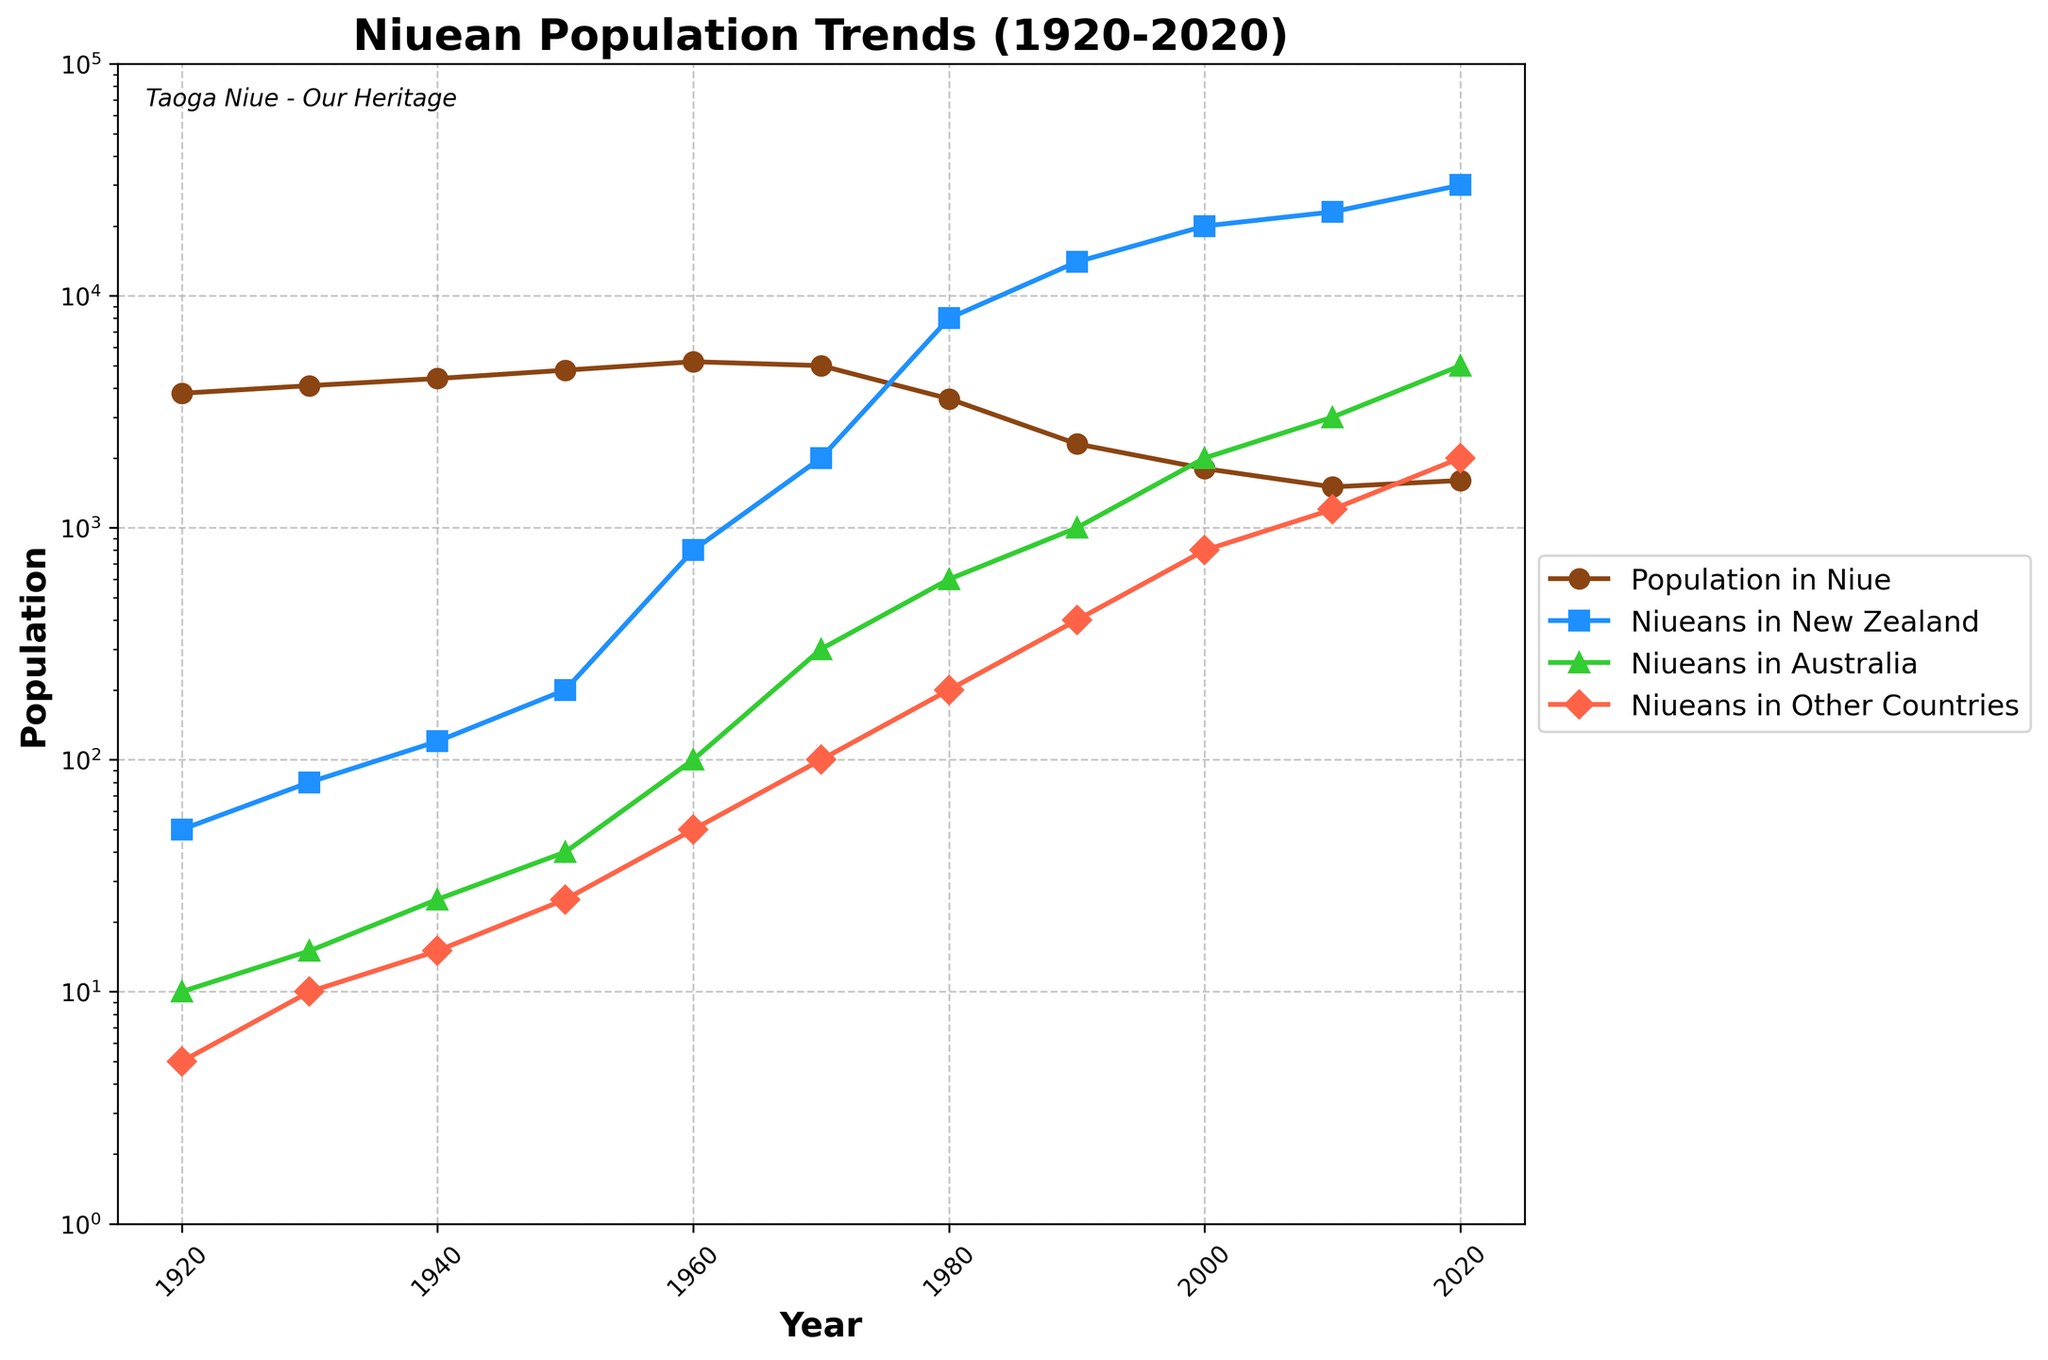What's the population trend within Niue from 1920 to 2020? To determine the population trend within Niue, we look at the part of the line chart corresponding to the Population_in_Niue. It shows an initial increase from 3800 in 1920 to a peak of 5200 in 1960. Then, it decreases significantly to 1600 by 2020. Thus, the overall trend from 1920 to 2020 is a decline.
Answer: Decline Which year saw the greatest number of Niueans leaving for New Zealand? We examine the line corresponding to Niueans_in_New_Zealand on the chart. By comparing the data points directly, we note that the highest point is in the year 2020 with 30,000 people.
Answer: 2020 In which decade did the population in Niue see the most drastic decline? To determine this, observe the gradient (steepness) of the line representing Population_in_Niue. The steepest decline is observed between 1970 (5000) and 1980 (3600), indicating the most drastic decline happened in the 1970s.
Answer: 1970s Compare the number of Niueans in New Zealand and Australia in 2020. Which country had more Niueans? From the lines, the data points for New Zealand and Australia in 2020 are 30,000 and 5,000, respectively. New Zealand had more Niueans.
Answer: New Zealand How did the Niuean population in other countries change from 1920 to 2020? We look at the line corresponding to Niueans_in_Other_Countries. The population grew from 5 in 1920 to 2,000 in 2020, showing an increase.
Answer: Increase During which decade did the Niuean population in Australia see the largest increase? Observing the trend line for Niueans_in_Australia, we note the steepest increase is between 2000 (2000) and 2010 (3000). This indicates the largest increase happened in the 2000s.
Answer: 2000s What is the sum of the Niuean populations in Niue and New Zealand in 2020? For 2020, the population in Niue is 1600 and in New Zealand is 30,000. Summing these gives 1600 + 30,000 = 31,600.
Answer: 31,600 Compare the relative visual heights of the lines for Niueans in New Zealand and Australia for the year 1980. Which is higher? In 1980, the line for Niueans_in_New_Zealand and Niueans_in_Australia are at 8,000 and 600, respectively. The line for New Zealand is visually much higher.
Answer: New Zealand Which location saw the largest numerical change in population in the decade from 1990 to 2000? We compare the changes in the decade from 1990 to 2000 for each line. For Niueans_in_New_Zealand, it increased from 14,000 to 20,000 (a change of 6,000). For Niueans_in_Australia, from 1000 to 2000 (change of 1,000). Niueans_in_Other_Countries changed from 400 to 800 (change of 400). Population_in_Niue decreased by 500. The largest numerical change is for Niueans in New Zealand (+6,000).
Answer: New Zealand 